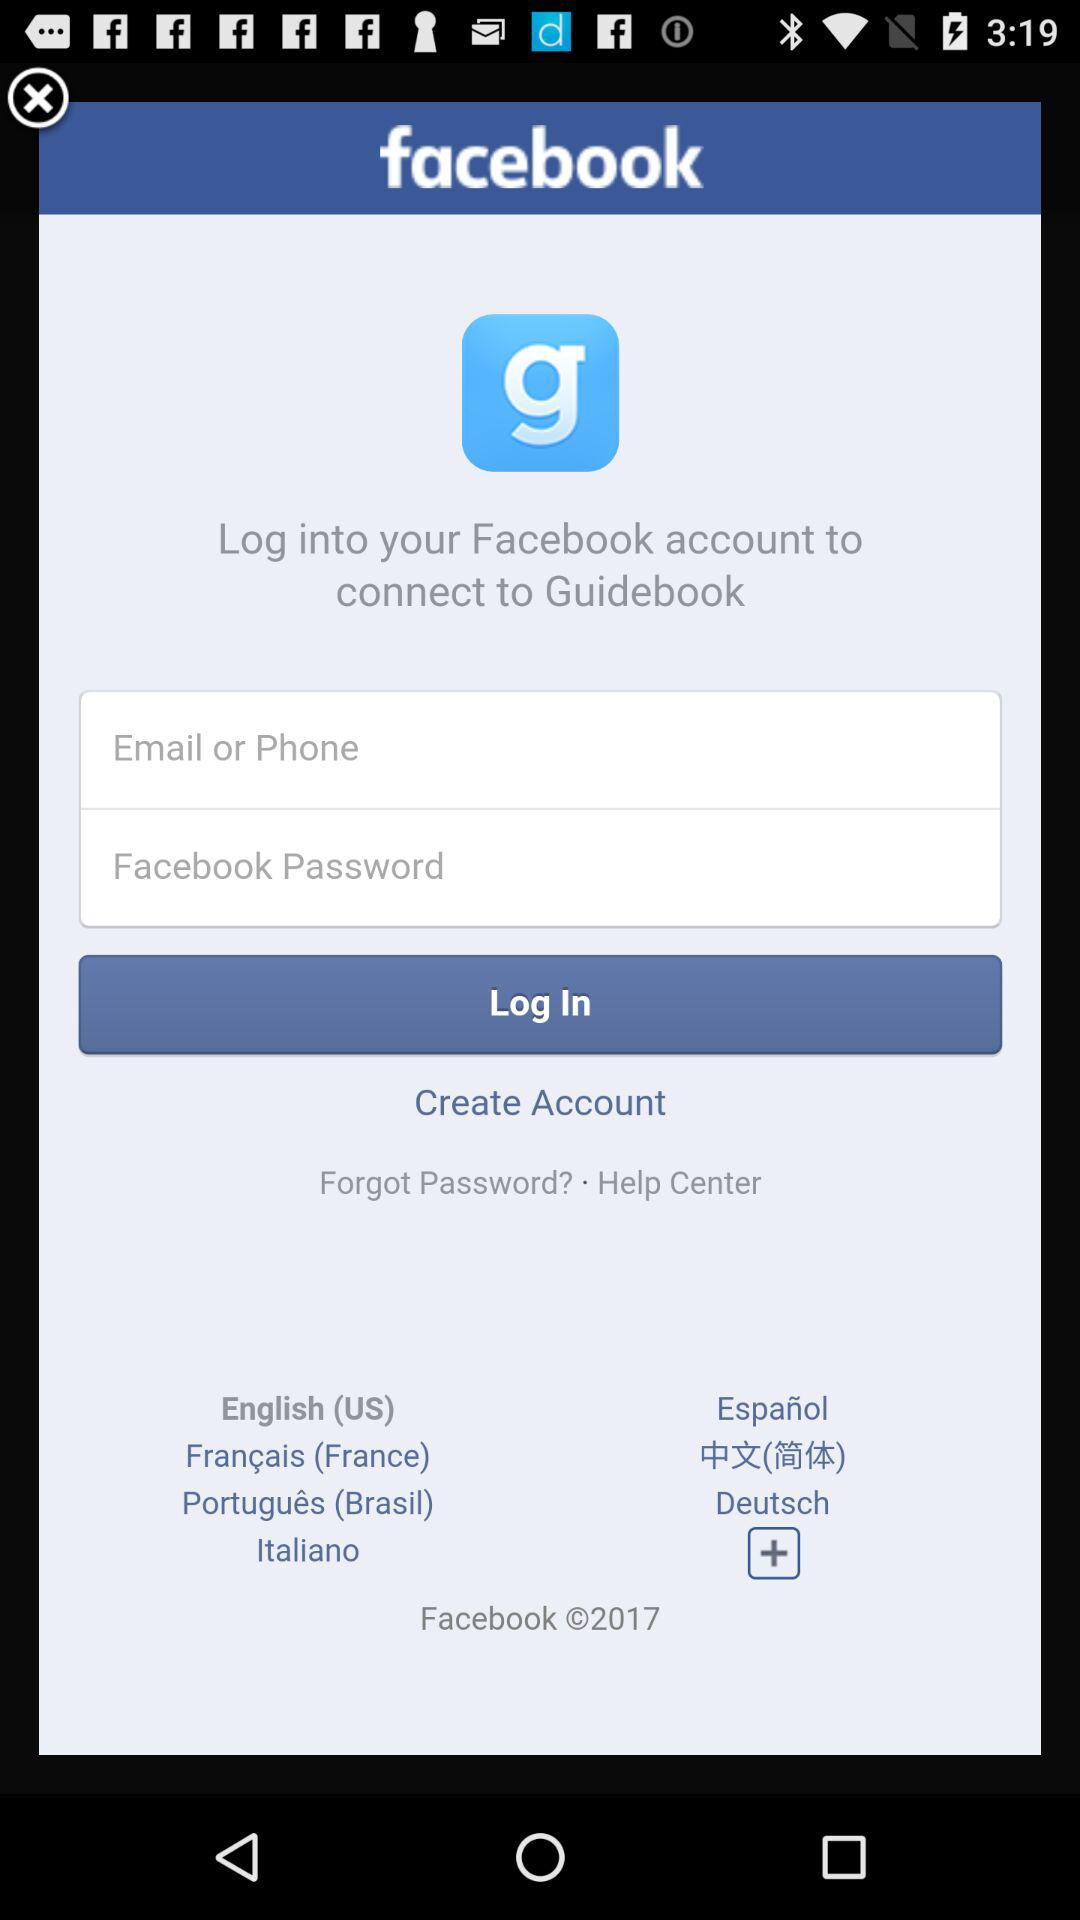What is the application name? The application name is "facebook". 